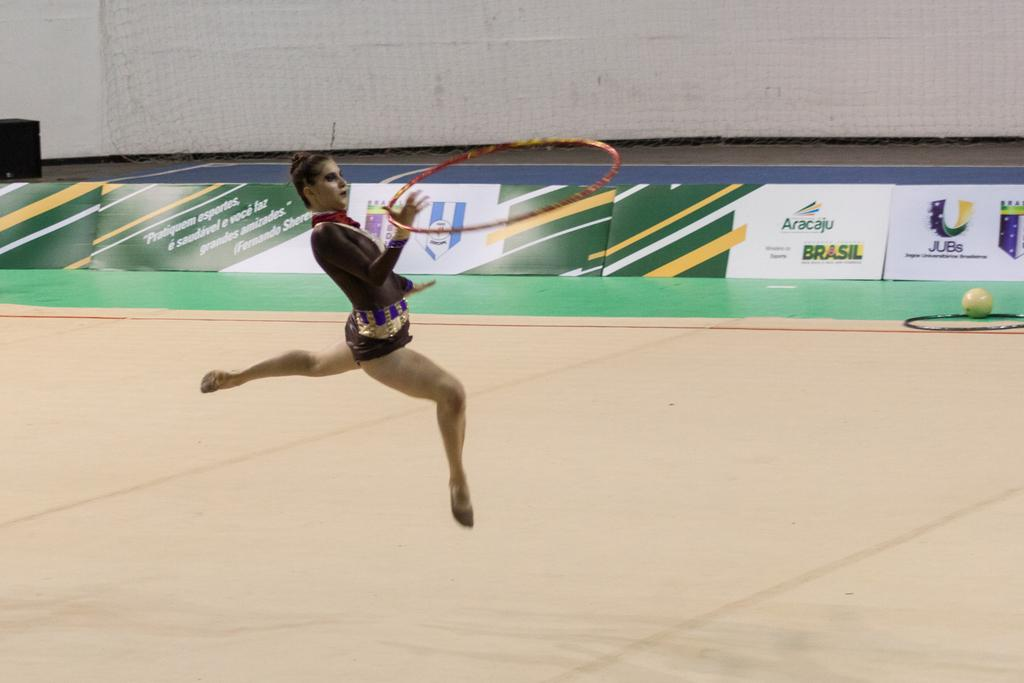<image>
Create a compact narrative representing the image presented. An Aracaju advertisement on the wall of a gymnastics competition 